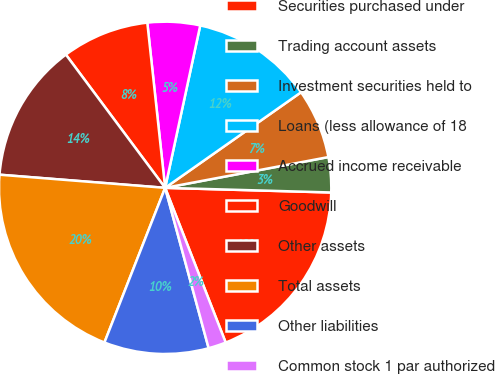Convert chart. <chart><loc_0><loc_0><loc_500><loc_500><pie_chart><fcel>Securities purchased under<fcel>Trading account assets<fcel>Investment securities held to<fcel>Loans (less allowance of 18<fcel>Accrued income receivable<fcel>Goodwill<fcel>Other assets<fcel>Total assets<fcel>Other liabilities<fcel>Common stock 1 par authorized<nl><fcel>18.62%<fcel>3.41%<fcel>6.79%<fcel>11.86%<fcel>5.1%<fcel>8.48%<fcel>13.55%<fcel>20.31%<fcel>10.17%<fcel>1.72%<nl></chart> 